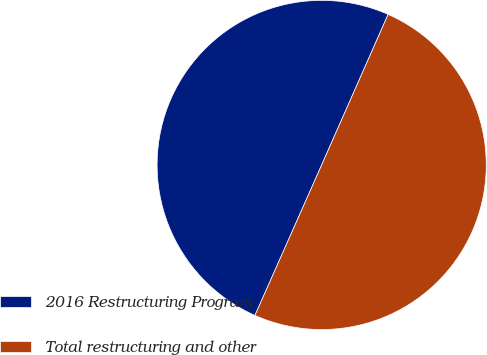<chart> <loc_0><loc_0><loc_500><loc_500><pie_chart><fcel>2016 Restructuring Program<fcel>Total restructuring and other<nl><fcel>49.97%<fcel>50.03%<nl></chart> 